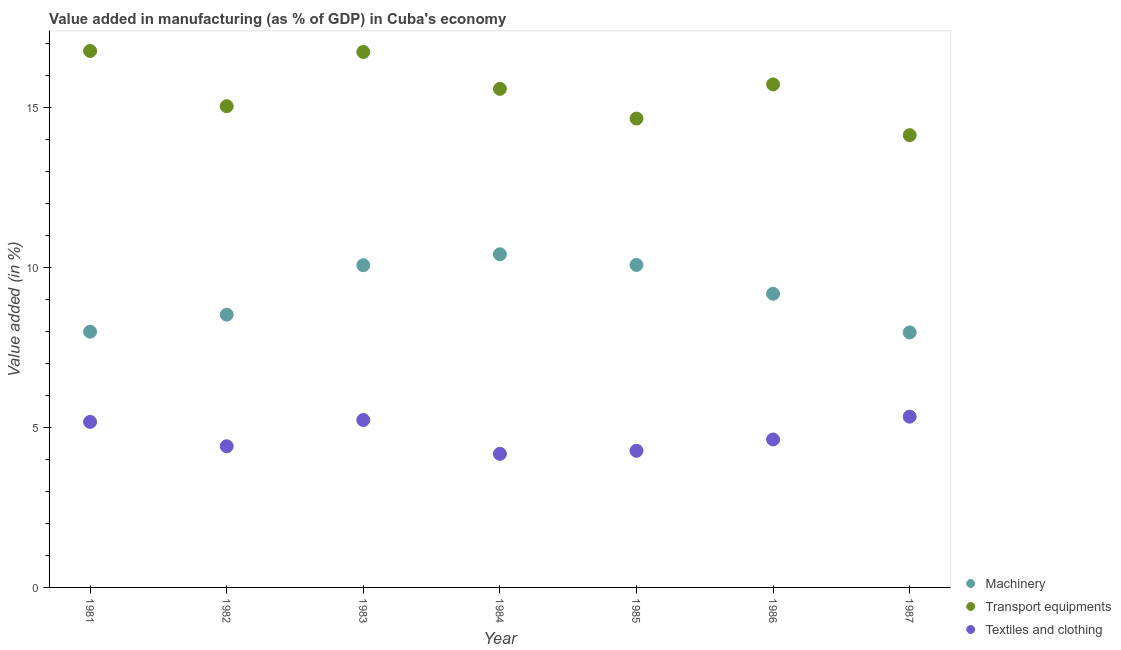What is the value added in manufacturing textile and clothing in 1987?
Your response must be concise. 5.34. Across all years, what is the maximum value added in manufacturing textile and clothing?
Provide a short and direct response. 5.34. Across all years, what is the minimum value added in manufacturing textile and clothing?
Offer a terse response. 4.18. In which year was the value added in manufacturing machinery minimum?
Provide a short and direct response. 1987. What is the total value added in manufacturing machinery in the graph?
Offer a very short reply. 64.27. What is the difference between the value added in manufacturing machinery in 1985 and that in 1986?
Make the answer very short. 0.9. What is the difference between the value added in manufacturing textile and clothing in 1987 and the value added in manufacturing machinery in 1986?
Give a very brief answer. -3.84. What is the average value added in manufacturing transport equipments per year?
Give a very brief answer. 15.53. In the year 1987, what is the difference between the value added in manufacturing transport equipments and value added in manufacturing textile and clothing?
Provide a short and direct response. 8.8. In how many years, is the value added in manufacturing transport equipments greater than 6 %?
Your answer should be very brief. 7. What is the ratio of the value added in manufacturing transport equipments in 1984 to that in 1985?
Ensure brevity in your answer.  1.06. What is the difference between the highest and the second highest value added in manufacturing transport equipments?
Your response must be concise. 0.03. What is the difference between the highest and the lowest value added in manufacturing textile and clothing?
Provide a short and direct response. 1.16. Does the value added in manufacturing textile and clothing monotonically increase over the years?
Provide a succinct answer. No. Is the value added in manufacturing transport equipments strictly greater than the value added in manufacturing textile and clothing over the years?
Your answer should be very brief. Yes. What is the difference between two consecutive major ticks on the Y-axis?
Offer a terse response. 5. Are the values on the major ticks of Y-axis written in scientific E-notation?
Give a very brief answer. No. Does the graph contain grids?
Keep it short and to the point. No. Where does the legend appear in the graph?
Your response must be concise. Bottom right. How are the legend labels stacked?
Your answer should be very brief. Vertical. What is the title of the graph?
Keep it short and to the point. Value added in manufacturing (as % of GDP) in Cuba's economy. What is the label or title of the X-axis?
Offer a very short reply. Year. What is the label or title of the Y-axis?
Keep it short and to the point. Value added (in %). What is the Value added (in %) in Machinery in 1981?
Give a very brief answer. 8. What is the Value added (in %) of Transport equipments in 1981?
Make the answer very short. 16.78. What is the Value added (in %) of Textiles and clothing in 1981?
Offer a terse response. 5.18. What is the Value added (in %) of Machinery in 1982?
Your response must be concise. 8.53. What is the Value added (in %) in Transport equipments in 1982?
Your response must be concise. 15.05. What is the Value added (in %) of Textiles and clothing in 1982?
Your answer should be very brief. 4.42. What is the Value added (in %) of Machinery in 1983?
Provide a short and direct response. 10.08. What is the Value added (in %) of Transport equipments in 1983?
Your answer should be very brief. 16.75. What is the Value added (in %) of Textiles and clothing in 1983?
Provide a short and direct response. 5.24. What is the Value added (in %) in Machinery in 1984?
Provide a short and direct response. 10.42. What is the Value added (in %) of Transport equipments in 1984?
Give a very brief answer. 15.59. What is the Value added (in %) in Textiles and clothing in 1984?
Keep it short and to the point. 4.18. What is the Value added (in %) of Machinery in 1985?
Provide a short and direct response. 10.09. What is the Value added (in %) of Transport equipments in 1985?
Your answer should be very brief. 14.66. What is the Value added (in %) of Textiles and clothing in 1985?
Ensure brevity in your answer.  4.27. What is the Value added (in %) of Machinery in 1986?
Provide a short and direct response. 9.18. What is the Value added (in %) of Transport equipments in 1986?
Your answer should be compact. 15.73. What is the Value added (in %) in Textiles and clothing in 1986?
Make the answer very short. 4.63. What is the Value added (in %) in Machinery in 1987?
Give a very brief answer. 7.97. What is the Value added (in %) of Transport equipments in 1987?
Give a very brief answer. 14.15. What is the Value added (in %) in Textiles and clothing in 1987?
Offer a terse response. 5.34. Across all years, what is the maximum Value added (in %) in Machinery?
Provide a succinct answer. 10.42. Across all years, what is the maximum Value added (in %) in Transport equipments?
Make the answer very short. 16.78. Across all years, what is the maximum Value added (in %) of Textiles and clothing?
Provide a short and direct response. 5.34. Across all years, what is the minimum Value added (in %) in Machinery?
Make the answer very short. 7.97. Across all years, what is the minimum Value added (in %) in Transport equipments?
Your response must be concise. 14.15. Across all years, what is the minimum Value added (in %) in Textiles and clothing?
Your response must be concise. 4.18. What is the total Value added (in %) of Machinery in the graph?
Your response must be concise. 64.27. What is the total Value added (in %) in Transport equipments in the graph?
Your response must be concise. 108.71. What is the total Value added (in %) of Textiles and clothing in the graph?
Your answer should be very brief. 33.25. What is the difference between the Value added (in %) of Machinery in 1981 and that in 1982?
Your response must be concise. -0.53. What is the difference between the Value added (in %) in Transport equipments in 1981 and that in 1982?
Make the answer very short. 1.73. What is the difference between the Value added (in %) in Textiles and clothing in 1981 and that in 1982?
Give a very brief answer. 0.76. What is the difference between the Value added (in %) in Machinery in 1981 and that in 1983?
Your response must be concise. -2.08. What is the difference between the Value added (in %) of Transport equipments in 1981 and that in 1983?
Your answer should be very brief. 0.03. What is the difference between the Value added (in %) of Textiles and clothing in 1981 and that in 1983?
Your answer should be very brief. -0.06. What is the difference between the Value added (in %) of Machinery in 1981 and that in 1984?
Your answer should be very brief. -2.42. What is the difference between the Value added (in %) of Transport equipments in 1981 and that in 1984?
Offer a terse response. 1.18. What is the difference between the Value added (in %) in Machinery in 1981 and that in 1985?
Make the answer very short. -2.09. What is the difference between the Value added (in %) of Transport equipments in 1981 and that in 1985?
Your response must be concise. 2.11. What is the difference between the Value added (in %) in Textiles and clothing in 1981 and that in 1985?
Ensure brevity in your answer.  0.9. What is the difference between the Value added (in %) of Machinery in 1981 and that in 1986?
Give a very brief answer. -1.19. What is the difference between the Value added (in %) in Transport equipments in 1981 and that in 1986?
Offer a very short reply. 1.05. What is the difference between the Value added (in %) in Textiles and clothing in 1981 and that in 1986?
Give a very brief answer. 0.55. What is the difference between the Value added (in %) of Machinery in 1981 and that in 1987?
Provide a succinct answer. 0.02. What is the difference between the Value added (in %) in Transport equipments in 1981 and that in 1987?
Provide a succinct answer. 2.63. What is the difference between the Value added (in %) in Textiles and clothing in 1981 and that in 1987?
Provide a short and direct response. -0.16. What is the difference between the Value added (in %) of Machinery in 1982 and that in 1983?
Provide a succinct answer. -1.55. What is the difference between the Value added (in %) in Transport equipments in 1982 and that in 1983?
Your response must be concise. -1.7. What is the difference between the Value added (in %) in Textiles and clothing in 1982 and that in 1983?
Your answer should be very brief. -0.82. What is the difference between the Value added (in %) of Machinery in 1982 and that in 1984?
Make the answer very short. -1.89. What is the difference between the Value added (in %) of Transport equipments in 1982 and that in 1984?
Ensure brevity in your answer.  -0.54. What is the difference between the Value added (in %) of Textiles and clothing in 1982 and that in 1984?
Make the answer very short. 0.24. What is the difference between the Value added (in %) of Machinery in 1982 and that in 1985?
Your answer should be very brief. -1.55. What is the difference between the Value added (in %) of Transport equipments in 1982 and that in 1985?
Your response must be concise. 0.39. What is the difference between the Value added (in %) of Textiles and clothing in 1982 and that in 1985?
Offer a very short reply. 0.14. What is the difference between the Value added (in %) of Machinery in 1982 and that in 1986?
Your response must be concise. -0.65. What is the difference between the Value added (in %) of Transport equipments in 1982 and that in 1986?
Your response must be concise. -0.68. What is the difference between the Value added (in %) of Textiles and clothing in 1982 and that in 1986?
Your answer should be compact. -0.21. What is the difference between the Value added (in %) of Machinery in 1982 and that in 1987?
Offer a very short reply. 0.56. What is the difference between the Value added (in %) of Transport equipments in 1982 and that in 1987?
Make the answer very short. 0.9. What is the difference between the Value added (in %) of Textiles and clothing in 1982 and that in 1987?
Provide a short and direct response. -0.93. What is the difference between the Value added (in %) in Machinery in 1983 and that in 1984?
Your answer should be very brief. -0.34. What is the difference between the Value added (in %) in Transport equipments in 1983 and that in 1984?
Keep it short and to the point. 1.15. What is the difference between the Value added (in %) in Textiles and clothing in 1983 and that in 1984?
Your response must be concise. 1.06. What is the difference between the Value added (in %) in Machinery in 1983 and that in 1985?
Your answer should be compact. -0.01. What is the difference between the Value added (in %) of Transport equipments in 1983 and that in 1985?
Your answer should be compact. 2.08. What is the difference between the Value added (in %) of Machinery in 1983 and that in 1986?
Ensure brevity in your answer.  0.89. What is the difference between the Value added (in %) in Transport equipments in 1983 and that in 1986?
Keep it short and to the point. 1.02. What is the difference between the Value added (in %) of Textiles and clothing in 1983 and that in 1986?
Offer a very short reply. 0.61. What is the difference between the Value added (in %) of Machinery in 1983 and that in 1987?
Offer a very short reply. 2.1. What is the difference between the Value added (in %) of Transport equipments in 1983 and that in 1987?
Give a very brief answer. 2.6. What is the difference between the Value added (in %) in Textiles and clothing in 1983 and that in 1987?
Ensure brevity in your answer.  -0.11. What is the difference between the Value added (in %) of Machinery in 1984 and that in 1985?
Ensure brevity in your answer.  0.33. What is the difference between the Value added (in %) in Transport equipments in 1984 and that in 1985?
Your response must be concise. 0.93. What is the difference between the Value added (in %) of Textiles and clothing in 1984 and that in 1985?
Provide a succinct answer. -0.1. What is the difference between the Value added (in %) of Machinery in 1984 and that in 1986?
Give a very brief answer. 1.24. What is the difference between the Value added (in %) of Transport equipments in 1984 and that in 1986?
Give a very brief answer. -0.14. What is the difference between the Value added (in %) in Textiles and clothing in 1984 and that in 1986?
Ensure brevity in your answer.  -0.45. What is the difference between the Value added (in %) in Machinery in 1984 and that in 1987?
Provide a short and direct response. 2.45. What is the difference between the Value added (in %) of Transport equipments in 1984 and that in 1987?
Your response must be concise. 1.45. What is the difference between the Value added (in %) of Textiles and clothing in 1984 and that in 1987?
Your answer should be very brief. -1.16. What is the difference between the Value added (in %) of Machinery in 1985 and that in 1986?
Your answer should be compact. 0.9. What is the difference between the Value added (in %) of Transport equipments in 1985 and that in 1986?
Offer a very short reply. -1.07. What is the difference between the Value added (in %) in Textiles and clothing in 1985 and that in 1986?
Your answer should be compact. -0.35. What is the difference between the Value added (in %) of Machinery in 1985 and that in 1987?
Provide a short and direct response. 2.11. What is the difference between the Value added (in %) in Transport equipments in 1985 and that in 1987?
Your response must be concise. 0.52. What is the difference between the Value added (in %) of Textiles and clothing in 1985 and that in 1987?
Make the answer very short. -1.07. What is the difference between the Value added (in %) in Machinery in 1986 and that in 1987?
Give a very brief answer. 1.21. What is the difference between the Value added (in %) in Transport equipments in 1986 and that in 1987?
Your response must be concise. 1.59. What is the difference between the Value added (in %) in Textiles and clothing in 1986 and that in 1987?
Your answer should be very brief. -0.71. What is the difference between the Value added (in %) in Machinery in 1981 and the Value added (in %) in Transport equipments in 1982?
Offer a very short reply. -7.05. What is the difference between the Value added (in %) in Machinery in 1981 and the Value added (in %) in Textiles and clothing in 1982?
Keep it short and to the point. 3.58. What is the difference between the Value added (in %) in Transport equipments in 1981 and the Value added (in %) in Textiles and clothing in 1982?
Your answer should be compact. 12.36. What is the difference between the Value added (in %) of Machinery in 1981 and the Value added (in %) of Transport equipments in 1983?
Your response must be concise. -8.75. What is the difference between the Value added (in %) of Machinery in 1981 and the Value added (in %) of Textiles and clothing in 1983?
Offer a very short reply. 2.76. What is the difference between the Value added (in %) of Transport equipments in 1981 and the Value added (in %) of Textiles and clothing in 1983?
Provide a succinct answer. 11.54. What is the difference between the Value added (in %) of Machinery in 1981 and the Value added (in %) of Transport equipments in 1984?
Your response must be concise. -7.6. What is the difference between the Value added (in %) in Machinery in 1981 and the Value added (in %) in Textiles and clothing in 1984?
Your answer should be very brief. 3.82. What is the difference between the Value added (in %) of Transport equipments in 1981 and the Value added (in %) of Textiles and clothing in 1984?
Your answer should be compact. 12.6. What is the difference between the Value added (in %) in Machinery in 1981 and the Value added (in %) in Transport equipments in 1985?
Provide a succinct answer. -6.67. What is the difference between the Value added (in %) in Machinery in 1981 and the Value added (in %) in Textiles and clothing in 1985?
Your answer should be very brief. 3.72. What is the difference between the Value added (in %) of Transport equipments in 1981 and the Value added (in %) of Textiles and clothing in 1985?
Give a very brief answer. 12.5. What is the difference between the Value added (in %) in Machinery in 1981 and the Value added (in %) in Transport equipments in 1986?
Your response must be concise. -7.73. What is the difference between the Value added (in %) of Machinery in 1981 and the Value added (in %) of Textiles and clothing in 1986?
Give a very brief answer. 3.37. What is the difference between the Value added (in %) of Transport equipments in 1981 and the Value added (in %) of Textiles and clothing in 1986?
Offer a terse response. 12.15. What is the difference between the Value added (in %) in Machinery in 1981 and the Value added (in %) in Transport equipments in 1987?
Ensure brevity in your answer.  -6.15. What is the difference between the Value added (in %) in Machinery in 1981 and the Value added (in %) in Textiles and clothing in 1987?
Provide a short and direct response. 2.66. What is the difference between the Value added (in %) of Transport equipments in 1981 and the Value added (in %) of Textiles and clothing in 1987?
Keep it short and to the point. 11.44. What is the difference between the Value added (in %) in Machinery in 1982 and the Value added (in %) in Transport equipments in 1983?
Ensure brevity in your answer.  -8.22. What is the difference between the Value added (in %) of Machinery in 1982 and the Value added (in %) of Textiles and clothing in 1983?
Offer a very short reply. 3.3. What is the difference between the Value added (in %) in Transport equipments in 1982 and the Value added (in %) in Textiles and clothing in 1983?
Provide a succinct answer. 9.81. What is the difference between the Value added (in %) of Machinery in 1982 and the Value added (in %) of Transport equipments in 1984?
Your answer should be compact. -7.06. What is the difference between the Value added (in %) of Machinery in 1982 and the Value added (in %) of Textiles and clothing in 1984?
Make the answer very short. 4.35. What is the difference between the Value added (in %) in Transport equipments in 1982 and the Value added (in %) in Textiles and clothing in 1984?
Make the answer very short. 10.87. What is the difference between the Value added (in %) of Machinery in 1982 and the Value added (in %) of Transport equipments in 1985?
Your answer should be very brief. -6.13. What is the difference between the Value added (in %) in Machinery in 1982 and the Value added (in %) in Textiles and clothing in 1985?
Keep it short and to the point. 4.26. What is the difference between the Value added (in %) of Transport equipments in 1982 and the Value added (in %) of Textiles and clothing in 1985?
Provide a short and direct response. 10.78. What is the difference between the Value added (in %) of Machinery in 1982 and the Value added (in %) of Transport equipments in 1986?
Provide a succinct answer. -7.2. What is the difference between the Value added (in %) in Machinery in 1982 and the Value added (in %) in Textiles and clothing in 1986?
Ensure brevity in your answer.  3.9. What is the difference between the Value added (in %) of Transport equipments in 1982 and the Value added (in %) of Textiles and clothing in 1986?
Give a very brief answer. 10.42. What is the difference between the Value added (in %) of Machinery in 1982 and the Value added (in %) of Transport equipments in 1987?
Your answer should be very brief. -5.61. What is the difference between the Value added (in %) in Machinery in 1982 and the Value added (in %) in Textiles and clothing in 1987?
Your response must be concise. 3.19. What is the difference between the Value added (in %) of Transport equipments in 1982 and the Value added (in %) of Textiles and clothing in 1987?
Offer a very short reply. 9.71. What is the difference between the Value added (in %) of Machinery in 1983 and the Value added (in %) of Transport equipments in 1984?
Make the answer very short. -5.52. What is the difference between the Value added (in %) of Machinery in 1983 and the Value added (in %) of Textiles and clothing in 1984?
Keep it short and to the point. 5.9. What is the difference between the Value added (in %) of Transport equipments in 1983 and the Value added (in %) of Textiles and clothing in 1984?
Keep it short and to the point. 12.57. What is the difference between the Value added (in %) in Machinery in 1983 and the Value added (in %) in Transport equipments in 1985?
Offer a terse response. -4.59. What is the difference between the Value added (in %) of Machinery in 1983 and the Value added (in %) of Textiles and clothing in 1985?
Keep it short and to the point. 5.8. What is the difference between the Value added (in %) of Transport equipments in 1983 and the Value added (in %) of Textiles and clothing in 1985?
Provide a short and direct response. 12.47. What is the difference between the Value added (in %) in Machinery in 1983 and the Value added (in %) in Transport equipments in 1986?
Make the answer very short. -5.65. What is the difference between the Value added (in %) of Machinery in 1983 and the Value added (in %) of Textiles and clothing in 1986?
Provide a short and direct response. 5.45. What is the difference between the Value added (in %) in Transport equipments in 1983 and the Value added (in %) in Textiles and clothing in 1986?
Keep it short and to the point. 12.12. What is the difference between the Value added (in %) of Machinery in 1983 and the Value added (in %) of Transport equipments in 1987?
Ensure brevity in your answer.  -4.07. What is the difference between the Value added (in %) of Machinery in 1983 and the Value added (in %) of Textiles and clothing in 1987?
Your answer should be very brief. 4.74. What is the difference between the Value added (in %) in Transport equipments in 1983 and the Value added (in %) in Textiles and clothing in 1987?
Make the answer very short. 11.41. What is the difference between the Value added (in %) of Machinery in 1984 and the Value added (in %) of Transport equipments in 1985?
Give a very brief answer. -4.24. What is the difference between the Value added (in %) of Machinery in 1984 and the Value added (in %) of Textiles and clothing in 1985?
Make the answer very short. 6.15. What is the difference between the Value added (in %) of Transport equipments in 1984 and the Value added (in %) of Textiles and clothing in 1985?
Give a very brief answer. 11.32. What is the difference between the Value added (in %) of Machinery in 1984 and the Value added (in %) of Transport equipments in 1986?
Your answer should be compact. -5.31. What is the difference between the Value added (in %) of Machinery in 1984 and the Value added (in %) of Textiles and clothing in 1986?
Make the answer very short. 5.79. What is the difference between the Value added (in %) in Transport equipments in 1984 and the Value added (in %) in Textiles and clothing in 1986?
Provide a short and direct response. 10.97. What is the difference between the Value added (in %) of Machinery in 1984 and the Value added (in %) of Transport equipments in 1987?
Make the answer very short. -3.73. What is the difference between the Value added (in %) of Machinery in 1984 and the Value added (in %) of Textiles and clothing in 1987?
Your response must be concise. 5.08. What is the difference between the Value added (in %) in Transport equipments in 1984 and the Value added (in %) in Textiles and clothing in 1987?
Ensure brevity in your answer.  10.25. What is the difference between the Value added (in %) of Machinery in 1985 and the Value added (in %) of Transport equipments in 1986?
Give a very brief answer. -5.65. What is the difference between the Value added (in %) of Machinery in 1985 and the Value added (in %) of Textiles and clothing in 1986?
Give a very brief answer. 5.46. What is the difference between the Value added (in %) of Transport equipments in 1985 and the Value added (in %) of Textiles and clothing in 1986?
Give a very brief answer. 10.04. What is the difference between the Value added (in %) of Machinery in 1985 and the Value added (in %) of Transport equipments in 1987?
Give a very brief answer. -4.06. What is the difference between the Value added (in %) in Machinery in 1985 and the Value added (in %) in Textiles and clothing in 1987?
Your response must be concise. 4.74. What is the difference between the Value added (in %) of Transport equipments in 1985 and the Value added (in %) of Textiles and clothing in 1987?
Provide a short and direct response. 9.32. What is the difference between the Value added (in %) in Machinery in 1986 and the Value added (in %) in Transport equipments in 1987?
Provide a succinct answer. -4.96. What is the difference between the Value added (in %) of Machinery in 1986 and the Value added (in %) of Textiles and clothing in 1987?
Offer a terse response. 3.84. What is the difference between the Value added (in %) of Transport equipments in 1986 and the Value added (in %) of Textiles and clothing in 1987?
Your response must be concise. 10.39. What is the average Value added (in %) of Machinery per year?
Keep it short and to the point. 9.18. What is the average Value added (in %) of Transport equipments per year?
Provide a short and direct response. 15.53. What is the average Value added (in %) in Textiles and clothing per year?
Provide a short and direct response. 4.75. In the year 1981, what is the difference between the Value added (in %) of Machinery and Value added (in %) of Transport equipments?
Provide a short and direct response. -8.78. In the year 1981, what is the difference between the Value added (in %) in Machinery and Value added (in %) in Textiles and clothing?
Give a very brief answer. 2.82. In the year 1981, what is the difference between the Value added (in %) of Transport equipments and Value added (in %) of Textiles and clothing?
Your answer should be very brief. 11.6. In the year 1982, what is the difference between the Value added (in %) in Machinery and Value added (in %) in Transport equipments?
Give a very brief answer. -6.52. In the year 1982, what is the difference between the Value added (in %) in Machinery and Value added (in %) in Textiles and clothing?
Offer a very short reply. 4.12. In the year 1982, what is the difference between the Value added (in %) of Transport equipments and Value added (in %) of Textiles and clothing?
Offer a terse response. 10.63. In the year 1983, what is the difference between the Value added (in %) in Machinery and Value added (in %) in Transport equipments?
Keep it short and to the point. -6.67. In the year 1983, what is the difference between the Value added (in %) of Machinery and Value added (in %) of Textiles and clothing?
Provide a succinct answer. 4.84. In the year 1983, what is the difference between the Value added (in %) in Transport equipments and Value added (in %) in Textiles and clothing?
Provide a short and direct response. 11.51. In the year 1984, what is the difference between the Value added (in %) in Machinery and Value added (in %) in Transport equipments?
Give a very brief answer. -5.17. In the year 1984, what is the difference between the Value added (in %) of Machinery and Value added (in %) of Textiles and clothing?
Give a very brief answer. 6.24. In the year 1984, what is the difference between the Value added (in %) in Transport equipments and Value added (in %) in Textiles and clothing?
Make the answer very short. 11.41. In the year 1985, what is the difference between the Value added (in %) in Machinery and Value added (in %) in Transport equipments?
Provide a succinct answer. -4.58. In the year 1985, what is the difference between the Value added (in %) of Machinery and Value added (in %) of Textiles and clothing?
Offer a terse response. 5.81. In the year 1985, what is the difference between the Value added (in %) of Transport equipments and Value added (in %) of Textiles and clothing?
Offer a terse response. 10.39. In the year 1986, what is the difference between the Value added (in %) in Machinery and Value added (in %) in Transport equipments?
Keep it short and to the point. -6.55. In the year 1986, what is the difference between the Value added (in %) in Machinery and Value added (in %) in Textiles and clothing?
Your answer should be very brief. 4.56. In the year 1986, what is the difference between the Value added (in %) in Transport equipments and Value added (in %) in Textiles and clothing?
Make the answer very short. 11.1. In the year 1987, what is the difference between the Value added (in %) of Machinery and Value added (in %) of Transport equipments?
Give a very brief answer. -6.17. In the year 1987, what is the difference between the Value added (in %) in Machinery and Value added (in %) in Textiles and clothing?
Provide a succinct answer. 2.63. In the year 1987, what is the difference between the Value added (in %) in Transport equipments and Value added (in %) in Textiles and clothing?
Make the answer very short. 8.8. What is the ratio of the Value added (in %) in Transport equipments in 1981 to that in 1982?
Your answer should be very brief. 1.11. What is the ratio of the Value added (in %) of Textiles and clothing in 1981 to that in 1982?
Offer a very short reply. 1.17. What is the ratio of the Value added (in %) of Machinery in 1981 to that in 1983?
Your answer should be compact. 0.79. What is the ratio of the Value added (in %) in Transport equipments in 1981 to that in 1983?
Ensure brevity in your answer.  1. What is the ratio of the Value added (in %) in Textiles and clothing in 1981 to that in 1983?
Make the answer very short. 0.99. What is the ratio of the Value added (in %) in Machinery in 1981 to that in 1984?
Keep it short and to the point. 0.77. What is the ratio of the Value added (in %) of Transport equipments in 1981 to that in 1984?
Keep it short and to the point. 1.08. What is the ratio of the Value added (in %) of Textiles and clothing in 1981 to that in 1984?
Your answer should be very brief. 1.24. What is the ratio of the Value added (in %) of Machinery in 1981 to that in 1985?
Offer a very short reply. 0.79. What is the ratio of the Value added (in %) in Transport equipments in 1981 to that in 1985?
Your answer should be very brief. 1.14. What is the ratio of the Value added (in %) of Textiles and clothing in 1981 to that in 1985?
Offer a very short reply. 1.21. What is the ratio of the Value added (in %) of Machinery in 1981 to that in 1986?
Make the answer very short. 0.87. What is the ratio of the Value added (in %) in Transport equipments in 1981 to that in 1986?
Your answer should be compact. 1.07. What is the ratio of the Value added (in %) in Textiles and clothing in 1981 to that in 1986?
Your answer should be very brief. 1.12. What is the ratio of the Value added (in %) of Transport equipments in 1981 to that in 1987?
Your response must be concise. 1.19. What is the ratio of the Value added (in %) in Textiles and clothing in 1981 to that in 1987?
Your answer should be very brief. 0.97. What is the ratio of the Value added (in %) in Machinery in 1982 to that in 1983?
Provide a succinct answer. 0.85. What is the ratio of the Value added (in %) in Transport equipments in 1982 to that in 1983?
Your answer should be compact. 0.9. What is the ratio of the Value added (in %) in Textiles and clothing in 1982 to that in 1983?
Your response must be concise. 0.84. What is the ratio of the Value added (in %) of Machinery in 1982 to that in 1984?
Ensure brevity in your answer.  0.82. What is the ratio of the Value added (in %) of Transport equipments in 1982 to that in 1984?
Your response must be concise. 0.97. What is the ratio of the Value added (in %) of Textiles and clothing in 1982 to that in 1984?
Provide a succinct answer. 1.06. What is the ratio of the Value added (in %) of Machinery in 1982 to that in 1985?
Give a very brief answer. 0.85. What is the ratio of the Value added (in %) of Transport equipments in 1982 to that in 1985?
Provide a short and direct response. 1.03. What is the ratio of the Value added (in %) in Textiles and clothing in 1982 to that in 1985?
Give a very brief answer. 1.03. What is the ratio of the Value added (in %) in Machinery in 1982 to that in 1986?
Offer a very short reply. 0.93. What is the ratio of the Value added (in %) of Transport equipments in 1982 to that in 1986?
Your answer should be compact. 0.96. What is the ratio of the Value added (in %) in Textiles and clothing in 1982 to that in 1986?
Offer a very short reply. 0.95. What is the ratio of the Value added (in %) in Machinery in 1982 to that in 1987?
Give a very brief answer. 1.07. What is the ratio of the Value added (in %) of Transport equipments in 1982 to that in 1987?
Offer a very short reply. 1.06. What is the ratio of the Value added (in %) in Textiles and clothing in 1982 to that in 1987?
Provide a short and direct response. 0.83. What is the ratio of the Value added (in %) in Machinery in 1983 to that in 1984?
Your answer should be very brief. 0.97. What is the ratio of the Value added (in %) of Transport equipments in 1983 to that in 1984?
Your response must be concise. 1.07. What is the ratio of the Value added (in %) in Textiles and clothing in 1983 to that in 1984?
Your response must be concise. 1.25. What is the ratio of the Value added (in %) in Transport equipments in 1983 to that in 1985?
Ensure brevity in your answer.  1.14. What is the ratio of the Value added (in %) in Textiles and clothing in 1983 to that in 1985?
Your answer should be compact. 1.23. What is the ratio of the Value added (in %) of Machinery in 1983 to that in 1986?
Keep it short and to the point. 1.1. What is the ratio of the Value added (in %) of Transport equipments in 1983 to that in 1986?
Your answer should be compact. 1.06. What is the ratio of the Value added (in %) of Textiles and clothing in 1983 to that in 1986?
Provide a succinct answer. 1.13. What is the ratio of the Value added (in %) of Machinery in 1983 to that in 1987?
Keep it short and to the point. 1.26. What is the ratio of the Value added (in %) in Transport equipments in 1983 to that in 1987?
Your answer should be very brief. 1.18. What is the ratio of the Value added (in %) in Textiles and clothing in 1983 to that in 1987?
Offer a very short reply. 0.98. What is the ratio of the Value added (in %) in Machinery in 1984 to that in 1985?
Make the answer very short. 1.03. What is the ratio of the Value added (in %) in Transport equipments in 1984 to that in 1985?
Ensure brevity in your answer.  1.06. What is the ratio of the Value added (in %) of Textiles and clothing in 1984 to that in 1985?
Provide a succinct answer. 0.98. What is the ratio of the Value added (in %) in Machinery in 1984 to that in 1986?
Provide a short and direct response. 1.13. What is the ratio of the Value added (in %) of Textiles and clothing in 1984 to that in 1986?
Make the answer very short. 0.9. What is the ratio of the Value added (in %) of Machinery in 1984 to that in 1987?
Make the answer very short. 1.31. What is the ratio of the Value added (in %) of Transport equipments in 1984 to that in 1987?
Keep it short and to the point. 1.1. What is the ratio of the Value added (in %) in Textiles and clothing in 1984 to that in 1987?
Keep it short and to the point. 0.78. What is the ratio of the Value added (in %) in Machinery in 1985 to that in 1986?
Your response must be concise. 1.1. What is the ratio of the Value added (in %) of Transport equipments in 1985 to that in 1986?
Provide a short and direct response. 0.93. What is the ratio of the Value added (in %) in Textiles and clothing in 1985 to that in 1986?
Make the answer very short. 0.92. What is the ratio of the Value added (in %) of Machinery in 1985 to that in 1987?
Ensure brevity in your answer.  1.26. What is the ratio of the Value added (in %) in Transport equipments in 1985 to that in 1987?
Give a very brief answer. 1.04. What is the ratio of the Value added (in %) of Textiles and clothing in 1985 to that in 1987?
Your answer should be compact. 0.8. What is the ratio of the Value added (in %) in Machinery in 1986 to that in 1987?
Ensure brevity in your answer.  1.15. What is the ratio of the Value added (in %) in Transport equipments in 1986 to that in 1987?
Keep it short and to the point. 1.11. What is the ratio of the Value added (in %) in Textiles and clothing in 1986 to that in 1987?
Your answer should be compact. 0.87. What is the difference between the highest and the second highest Value added (in %) in Machinery?
Ensure brevity in your answer.  0.33. What is the difference between the highest and the second highest Value added (in %) in Transport equipments?
Your response must be concise. 0.03. What is the difference between the highest and the second highest Value added (in %) in Textiles and clothing?
Offer a very short reply. 0.11. What is the difference between the highest and the lowest Value added (in %) in Machinery?
Ensure brevity in your answer.  2.45. What is the difference between the highest and the lowest Value added (in %) in Transport equipments?
Your answer should be very brief. 2.63. What is the difference between the highest and the lowest Value added (in %) of Textiles and clothing?
Offer a terse response. 1.16. 